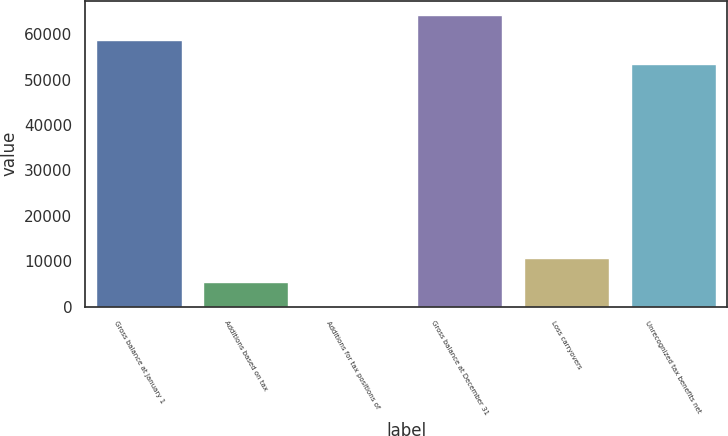<chart> <loc_0><loc_0><loc_500><loc_500><bar_chart><fcel>Gross balance at January 1<fcel>Additions based on tax<fcel>Additions for tax positions of<fcel>Gross balance at December 31<fcel>Loss carryovers<fcel>Unrecognized tax benefits net<nl><fcel>58775.9<fcel>5432.9<fcel>48<fcel>64160.8<fcel>10817.8<fcel>53391<nl></chart> 